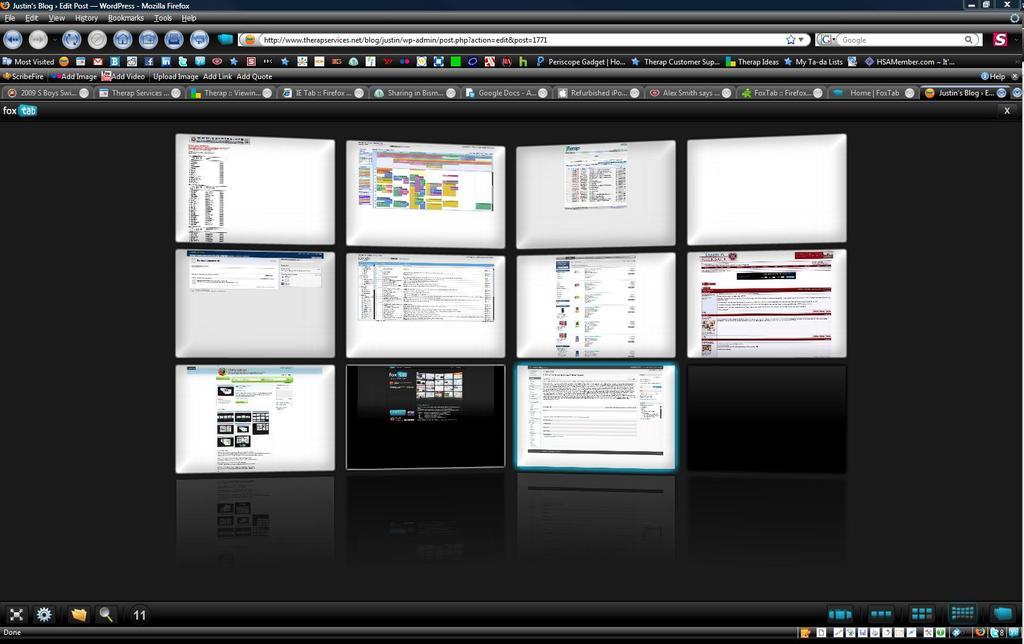How many webpages is open?
Provide a succinct answer. Answering does not require reading text in the image. Is this a fox tab?
Your response must be concise. Yes. 